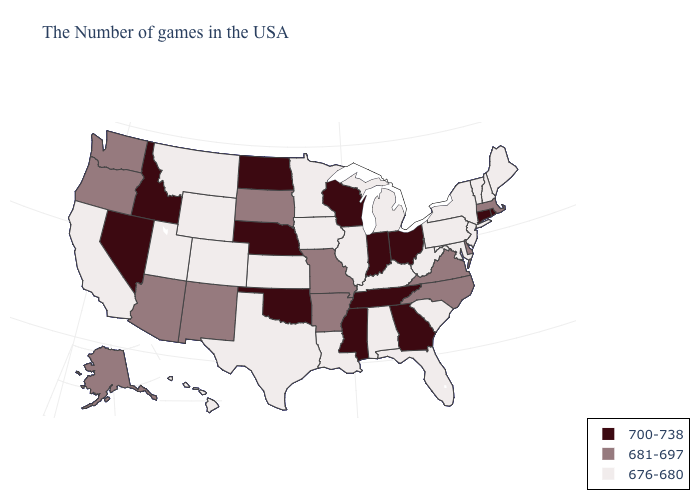Is the legend a continuous bar?
Write a very short answer. No. What is the value of New Hampshire?
Be succinct. 676-680. What is the value of Iowa?
Be succinct. 676-680. Does Kentucky have the highest value in the South?
Give a very brief answer. No. Does Indiana have a higher value than South Dakota?
Short answer required. Yes. Among the states that border California , does Oregon have the lowest value?
Quick response, please. Yes. How many symbols are there in the legend?
Write a very short answer. 3. What is the highest value in the South ?
Short answer required. 700-738. Among the states that border Rhode Island , does Connecticut have the highest value?
Quick response, please. Yes. What is the value of Massachusetts?
Give a very brief answer. 681-697. How many symbols are there in the legend?
Short answer required. 3. What is the lowest value in the USA?
Be succinct. 676-680. What is the value of Michigan?
Give a very brief answer. 676-680. Does the map have missing data?
Short answer required. No. Does Utah have the lowest value in the West?
Short answer required. Yes. 